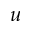Convert formula to latex. <formula><loc_0><loc_0><loc_500><loc_500>u</formula> 